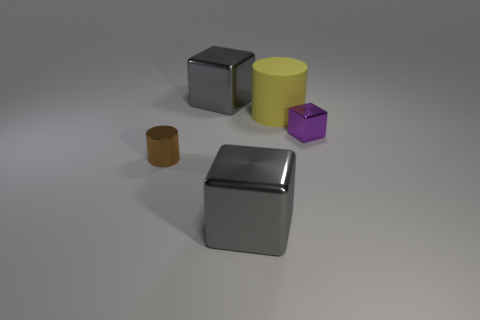How many metal blocks have the same size as the metallic cylinder?
Your answer should be very brief. 1. How many gray objects are behind the purple metal object?
Keep it short and to the point. 1. There is a tiny brown thing that is left of the large cube in front of the brown shiny cylinder; what is it made of?
Your answer should be compact. Metal. Are there any other objects of the same color as the rubber object?
Ensure brevity in your answer.  No. There is a cylinder that is made of the same material as the purple cube; what is its size?
Provide a short and direct response. Small. Are there any other things that have the same color as the tiny metal cylinder?
Give a very brief answer. No. What color is the large metal block that is behind the matte thing?
Your response must be concise. Gray. Are there any gray metallic cubes in front of the cylinder that is left of the large rubber thing behind the tiny brown cylinder?
Ensure brevity in your answer.  Yes. Are there more cubes that are behind the tiny brown thing than yellow cylinders?
Give a very brief answer. Yes. Does the gray metallic object that is behind the tiny cylinder have the same shape as the tiny purple thing?
Make the answer very short. Yes. 